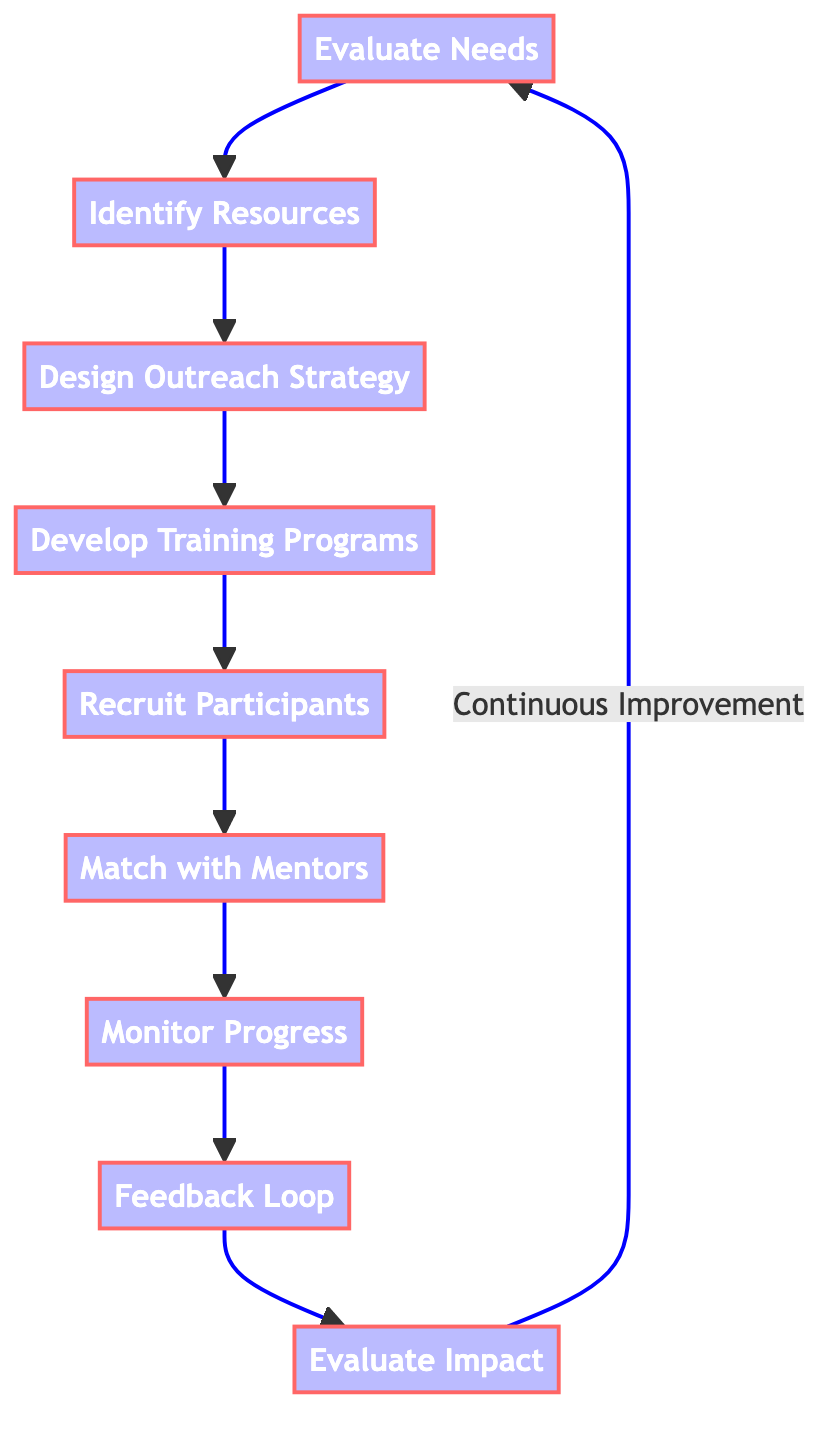What is the first step in the process? The diagram indicates that the first step in the process is to "Evaluate Needs," which is the starting point of the flowchart.
Answer: Evaluate Needs How many main steps are outlined in the diagram? The diagram outlines nine main steps from "Evaluate Needs" to "Evaluate Impact," counting each distinct box as a step.
Answer: Nine What step follows "Design Outreach Strategy"? Following "Design Outreach Strategy," the next step is "Develop Training Programs," which is the next node in the sequence.
Answer: Develop Training Programs Which step includes participant feedback? The "Feedback Loop" step is dedicated to collecting feedback from participants and mentors, as indicated in the diagram.
Answer: Feedback Loop What step ends the outreach program evaluation? The last step in the process is "Evaluate Impact," which summarizes the success and effectiveness of the outreach program.
Answer: Evaluate Impact What is the relationship between "Recruit Participants" and "Match with Mentors"? The relationship is sequential; "Recruit Participants" directly leads to "Match with Mentors," indicating that participants are recruited first before being matched with mentors.
Answer: Sequential What step is indicated by the arrow returning to "Evaluate Needs"? The arrow returning to "Evaluate Needs" represents the concept of "Continuous Improvement" which suggests that the evaluation process is cyclical and ongoing.
Answer: Continuous Improvement What type of support is included in the "Develop Training Programs" step? The "Develop Training Programs" step includes training focused on "entrepreneurship skills, mental health support, and personal development workshops."
Answer: Entrepreneurship skills, mental health support, personal development workshops Which node serves as a decision point for adjustments in the program? "Monitor Progress" serves as a decision point where regular assessments allow for necessary adjustments in the program based on participant engagement and development.
Answer: Monitor Progress 